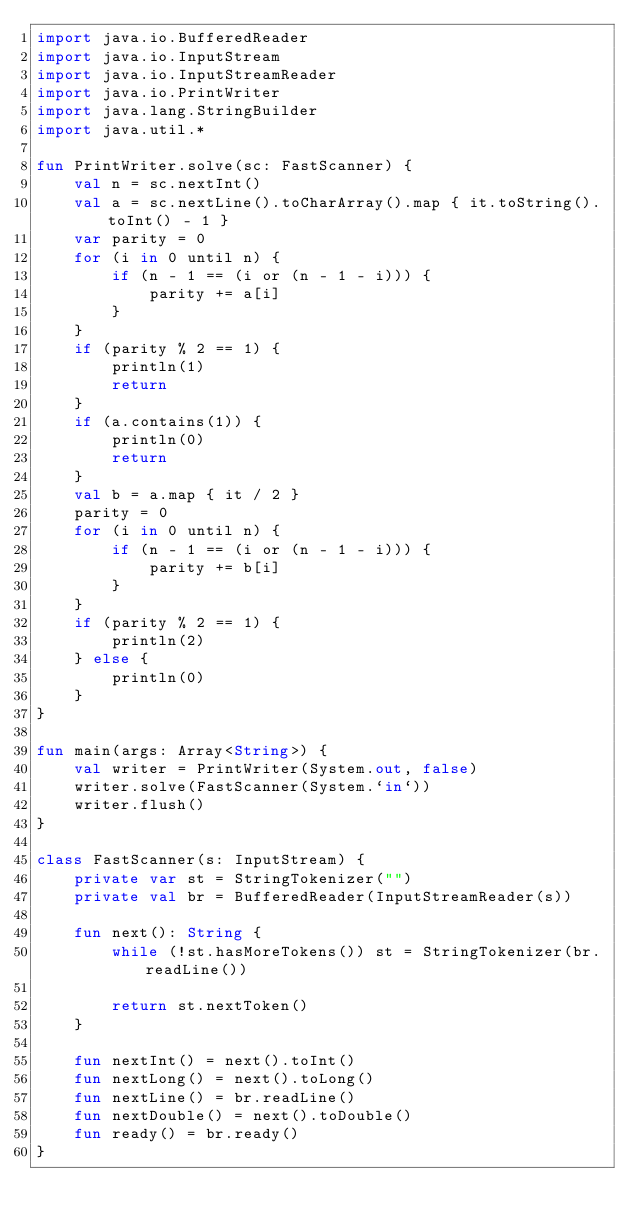<code> <loc_0><loc_0><loc_500><loc_500><_Kotlin_>import java.io.BufferedReader
import java.io.InputStream
import java.io.InputStreamReader
import java.io.PrintWriter
import java.lang.StringBuilder
import java.util.*

fun PrintWriter.solve(sc: FastScanner) {
    val n = sc.nextInt()
    val a = sc.nextLine().toCharArray().map { it.toString().toInt() - 1 }
    var parity = 0
    for (i in 0 until n) {
        if (n - 1 == (i or (n - 1 - i))) {
            parity += a[i]
        }
    }
    if (parity % 2 == 1) {
        println(1)
        return
    }
    if (a.contains(1)) {
        println(0)
        return
    }
    val b = a.map { it / 2 }
    parity = 0
    for (i in 0 until n) {
        if (n - 1 == (i or (n - 1 - i))) {
            parity += b[i]
        }
    }
    if (parity % 2 == 1) {
        println(2)
    } else {
        println(0)
    }
}

fun main(args: Array<String>) {
    val writer = PrintWriter(System.out, false)
    writer.solve(FastScanner(System.`in`))
    writer.flush()
}

class FastScanner(s: InputStream) {
    private var st = StringTokenizer("")
    private val br = BufferedReader(InputStreamReader(s))

    fun next(): String {
        while (!st.hasMoreTokens()) st = StringTokenizer(br.readLine())

        return st.nextToken()
    }

    fun nextInt() = next().toInt()
    fun nextLong() = next().toLong()
    fun nextLine() = br.readLine()
    fun nextDouble() = next().toDouble()
    fun ready() = br.ready()
}
</code> 